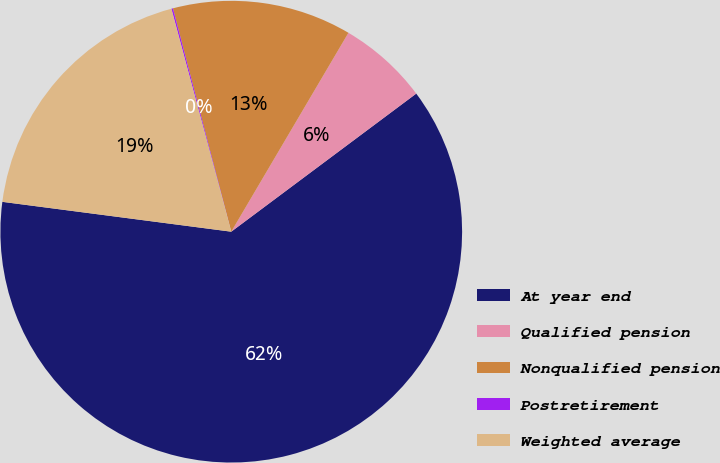Convert chart to OTSL. <chart><loc_0><loc_0><loc_500><loc_500><pie_chart><fcel>At year end<fcel>Qualified pension<fcel>Nonqualified pension<fcel>Postretirement<fcel>Weighted average<nl><fcel>62.27%<fcel>6.32%<fcel>12.54%<fcel>0.11%<fcel>18.76%<nl></chart> 